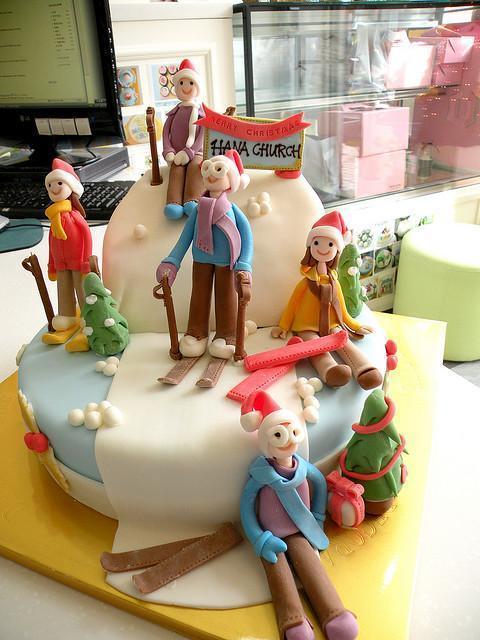How many ski are there?
Give a very brief answer. 2. 